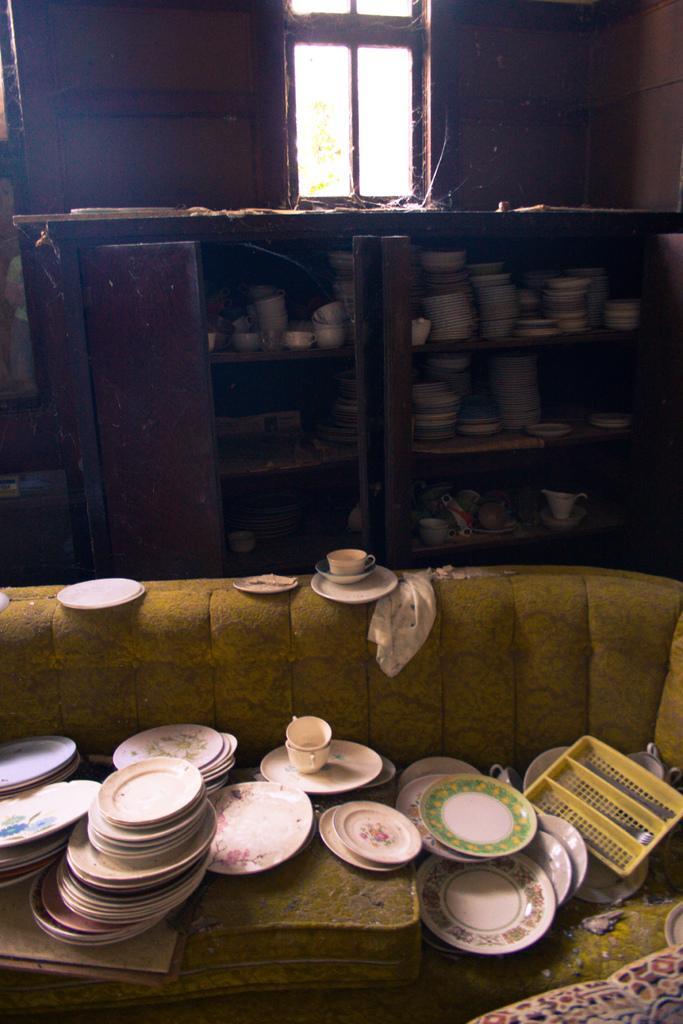Describe this image in one or two sentences. In the image there is a sofa with tea cups and saucers on it and in the back there is a rack with many bowls and dishes in it followed by a window on the wall. 